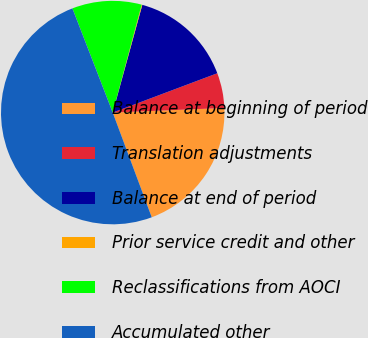Convert chart. <chart><loc_0><loc_0><loc_500><loc_500><pie_chart><fcel>Balance at beginning of period<fcel>Translation adjustments<fcel>Balance at end of period<fcel>Prior service credit and other<fcel>Reclassifications from AOCI<fcel>Accumulated other<nl><fcel>19.98%<fcel>5.07%<fcel>15.01%<fcel>0.1%<fcel>10.04%<fcel>49.8%<nl></chart> 